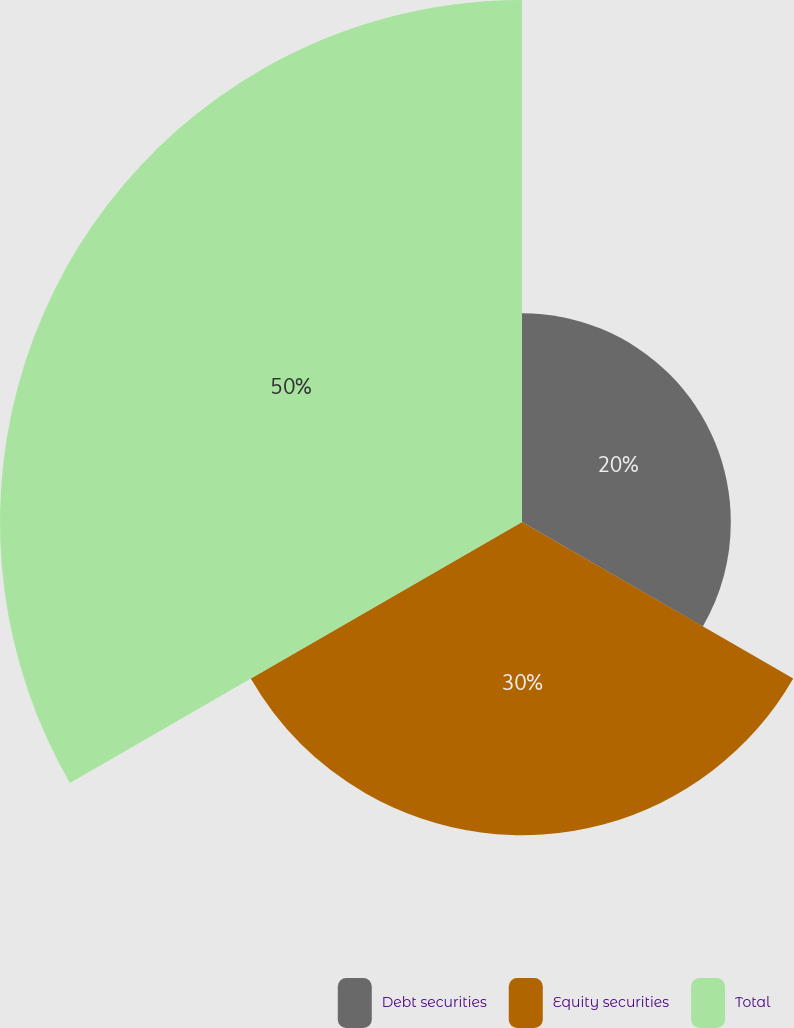Convert chart to OTSL. <chart><loc_0><loc_0><loc_500><loc_500><pie_chart><fcel>Debt securities<fcel>Equity securities<fcel>Total<nl><fcel>20.0%<fcel>30.0%<fcel>50.0%<nl></chart> 